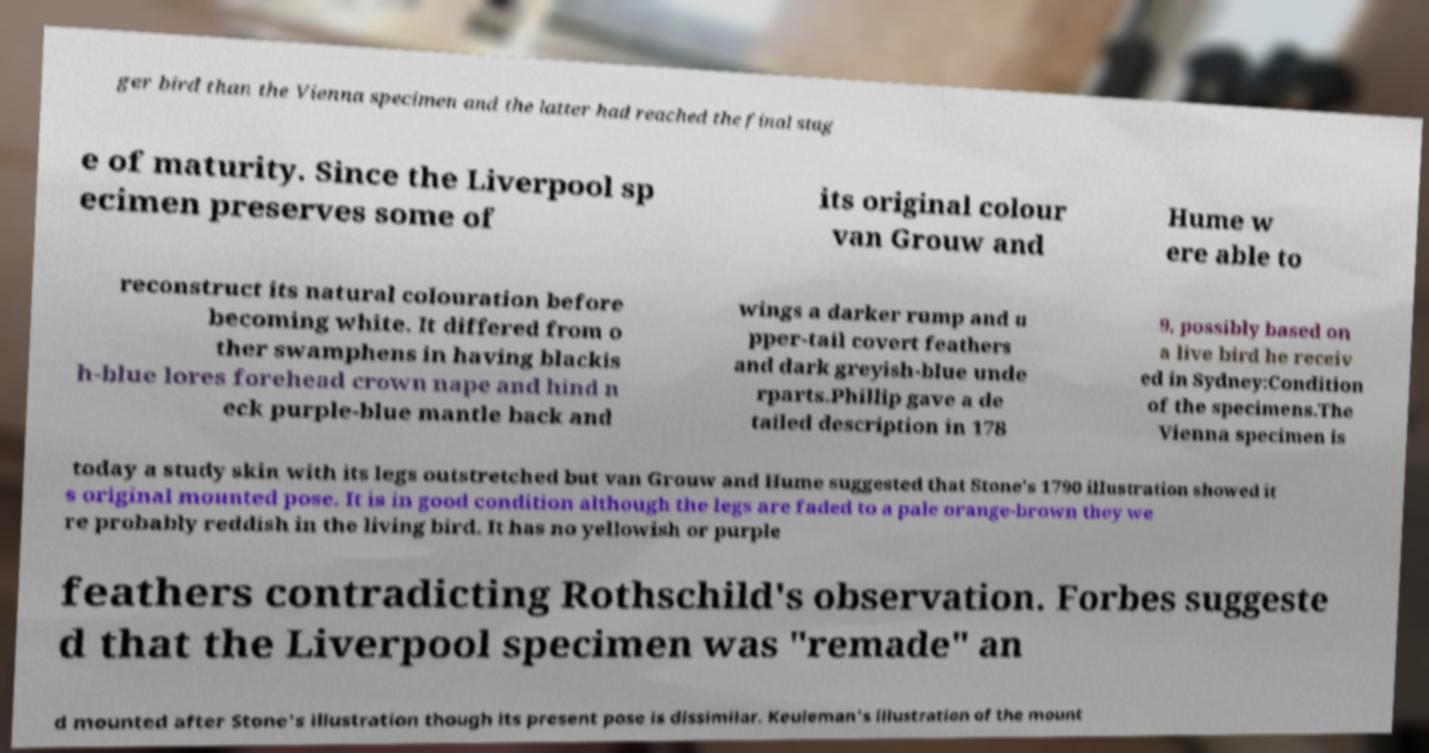Can you read and provide the text displayed in the image?This photo seems to have some interesting text. Can you extract and type it out for me? ger bird than the Vienna specimen and the latter had reached the final stag e of maturity. Since the Liverpool sp ecimen preserves some of its original colour van Grouw and Hume w ere able to reconstruct its natural colouration before becoming white. It differed from o ther swamphens in having blackis h-blue lores forehead crown nape and hind n eck purple-blue mantle back and wings a darker rump and u pper-tail covert feathers and dark greyish-blue unde rparts.Phillip gave a de tailed description in 178 9, possibly based on a live bird he receiv ed in Sydney:Condition of the specimens.The Vienna specimen is today a study skin with its legs outstretched but van Grouw and Hume suggested that Stone's 1790 illustration showed it s original mounted pose. It is in good condition although the legs are faded to a pale orange-brown they we re probably reddish in the living bird. It has no yellowish or purple feathers contradicting Rothschild's observation. Forbes suggeste d that the Liverpool specimen was "remade" an d mounted after Stone's illustration though its present pose is dissimilar. Keuleman's illustration of the mount 